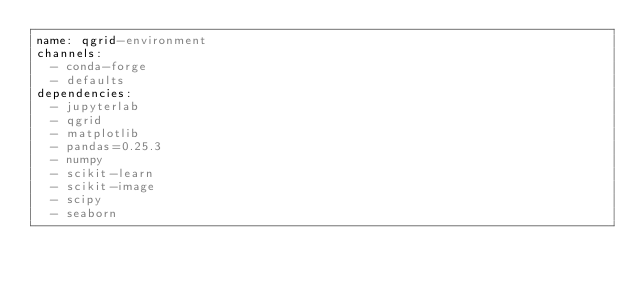Convert code to text. <code><loc_0><loc_0><loc_500><loc_500><_YAML_>name: qgrid-environment
channels:
  - conda-forge
  - defaults
dependencies:
  - jupyterlab
  - qgrid  
  - matplotlib
  - pandas=0.25.3
  - numpy
  - scikit-learn
  - scikit-image
  - scipy
  - seaborn
</code> 